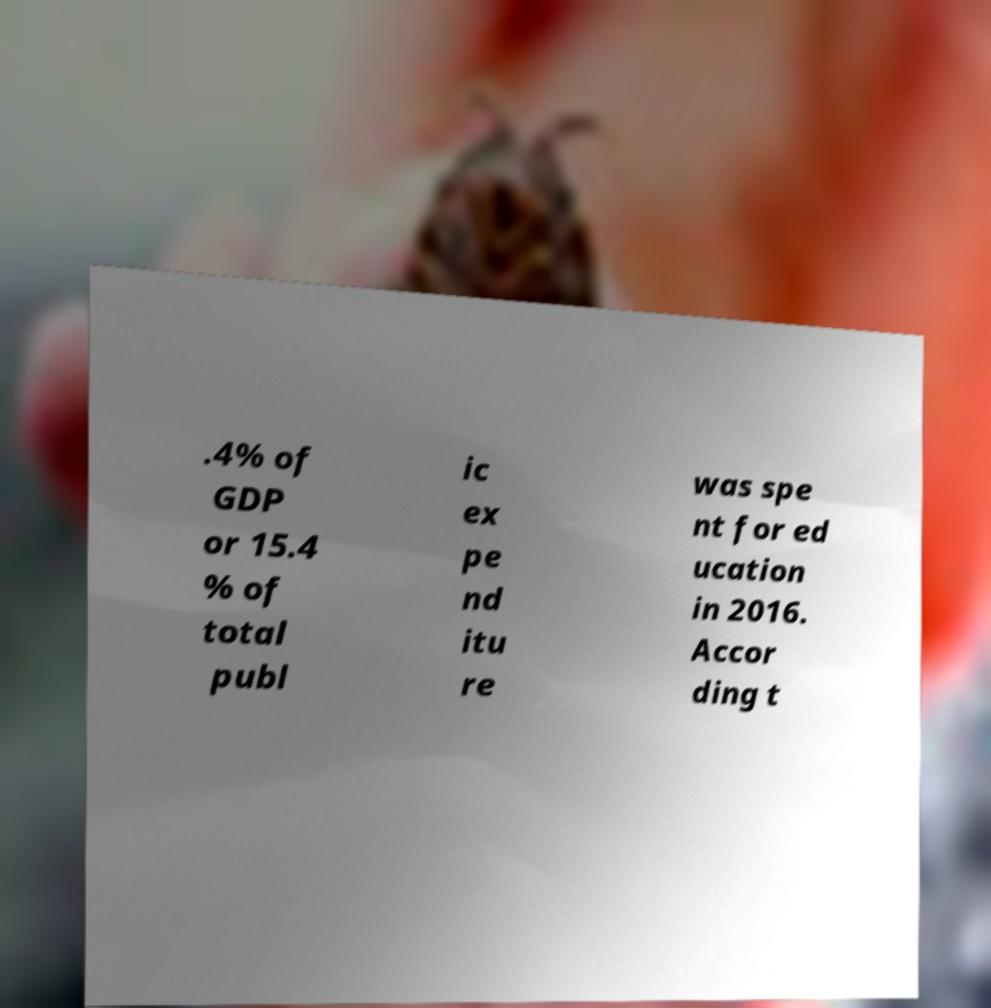What messages or text are displayed in this image? I need them in a readable, typed format. .4% of GDP or 15.4 % of total publ ic ex pe nd itu re was spe nt for ed ucation in 2016. Accor ding t 